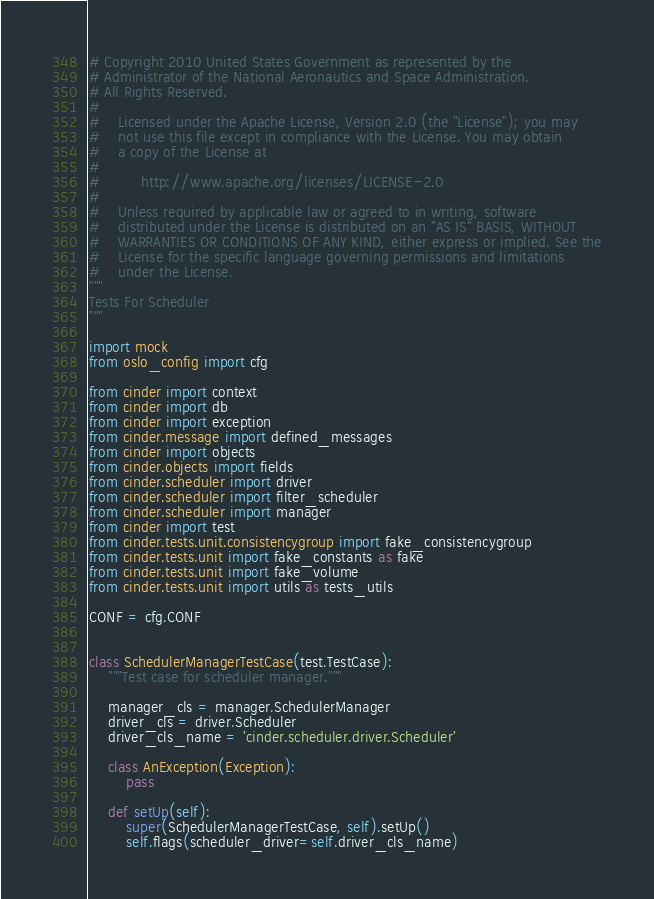<code> <loc_0><loc_0><loc_500><loc_500><_Python_># Copyright 2010 United States Government as represented by the
# Administrator of the National Aeronautics and Space Administration.
# All Rights Reserved.
#
#    Licensed under the Apache License, Version 2.0 (the "License"); you may
#    not use this file except in compliance with the License. You may obtain
#    a copy of the License at
#
#         http://www.apache.org/licenses/LICENSE-2.0
#
#    Unless required by applicable law or agreed to in writing, software
#    distributed under the License is distributed on an "AS IS" BASIS, WITHOUT
#    WARRANTIES OR CONDITIONS OF ANY KIND, either express or implied. See the
#    License for the specific language governing permissions and limitations
#    under the License.
"""
Tests For Scheduler
"""

import mock
from oslo_config import cfg

from cinder import context
from cinder import db
from cinder import exception
from cinder.message import defined_messages
from cinder import objects
from cinder.objects import fields
from cinder.scheduler import driver
from cinder.scheduler import filter_scheduler
from cinder.scheduler import manager
from cinder import test
from cinder.tests.unit.consistencygroup import fake_consistencygroup
from cinder.tests.unit import fake_constants as fake
from cinder.tests.unit import fake_volume
from cinder.tests.unit import utils as tests_utils

CONF = cfg.CONF


class SchedulerManagerTestCase(test.TestCase):
    """Test case for scheduler manager."""

    manager_cls = manager.SchedulerManager
    driver_cls = driver.Scheduler
    driver_cls_name = 'cinder.scheduler.driver.Scheduler'

    class AnException(Exception):
        pass

    def setUp(self):
        super(SchedulerManagerTestCase, self).setUp()
        self.flags(scheduler_driver=self.driver_cls_name)</code> 